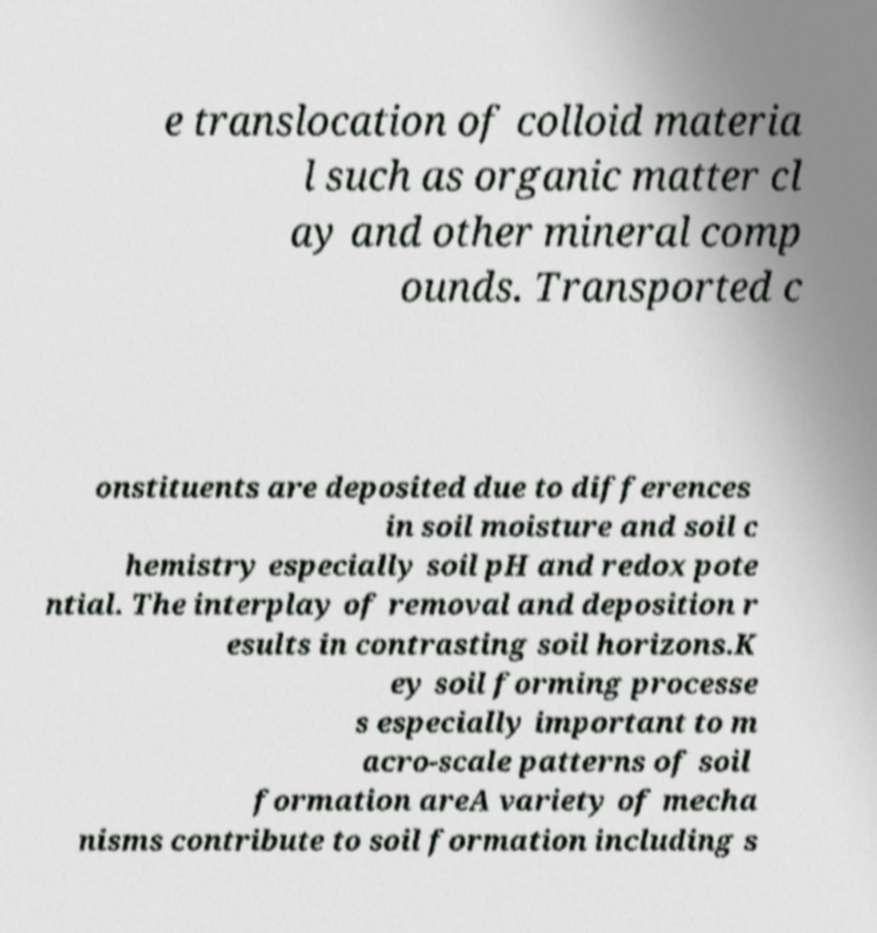Can you read and provide the text displayed in the image?This photo seems to have some interesting text. Can you extract and type it out for me? e translocation of colloid materia l such as organic matter cl ay and other mineral comp ounds. Transported c onstituents are deposited due to differences in soil moisture and soil c hemistry especially soil pH and redox pote ntial. The interplay of removal and deposition r esults in contrasting soil horizons.K ey soil forming processe s especially important to m acro-scale patterns of soil formation areA variety of mecha nisms contribute to soil formation including s 